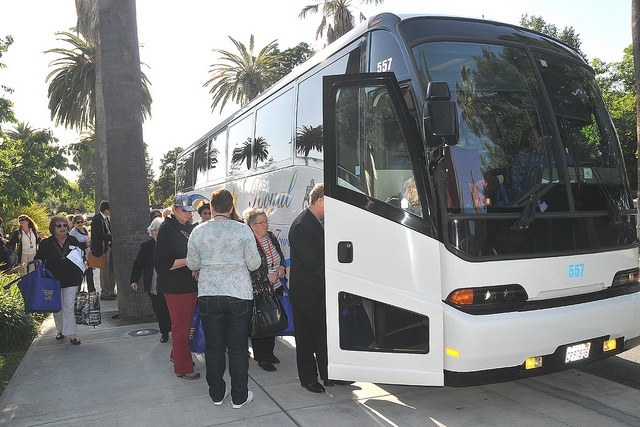Describe the objects in this image and their specific colors. I can see bus in white, black, lightgray, purple, and darkgray tones, people in white, black, darkgray, and lightgray tones, people in white, black, gray, and salmon tones, people in white, black, maroon, and gray tones, and people in white, black, and gray tones in this image. 